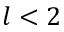<formula> <loc_0><loc_0><loc_500><loc_500>l < 2</formula> 